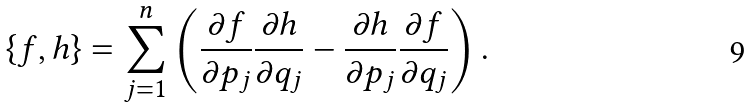<formula> <loc_0><loc_0><loc_500><loc_500>\{ f , h \} = \sum _ { j = 1 } ^ { n } \left ( \frac { \partial f } { \partial p _ { j } } \frac { \partial h } { \partial q _ { j } } - \frac { \partial h } { \partial p _ { j } } \frac { \partial f } { \partial q _ { j } } \right ) .</formula> 